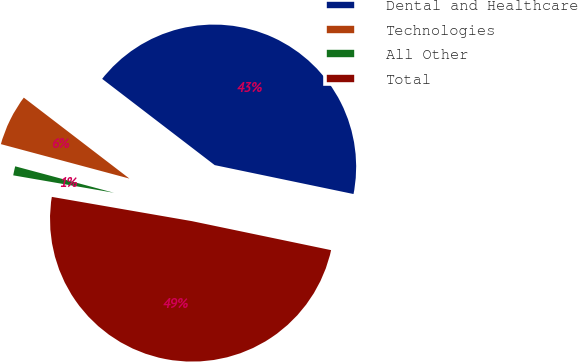Convert chart. <chart><loc_0><loc_0><loc_500><loc_500><pie_chart><fcel>Dental and Healthcare<fcel>Technologies<fcel>All Other<fcel>Total<nl><fcel>42.86%<fcel>6.24%<fcel>1.44%<fcel>49.46%<nl></chart> 